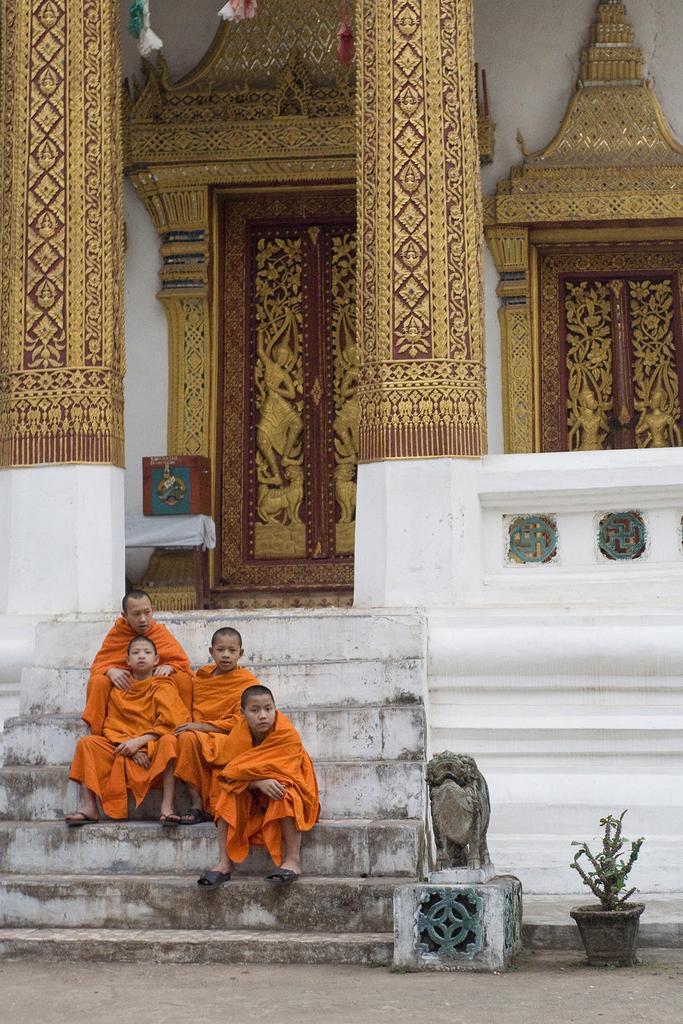How would you summarize this image in a sentence or two? There are people sitting on steps,beside these steps we can see statue and we can see house plant. In the background we can see pillars,wall,doors and box. 